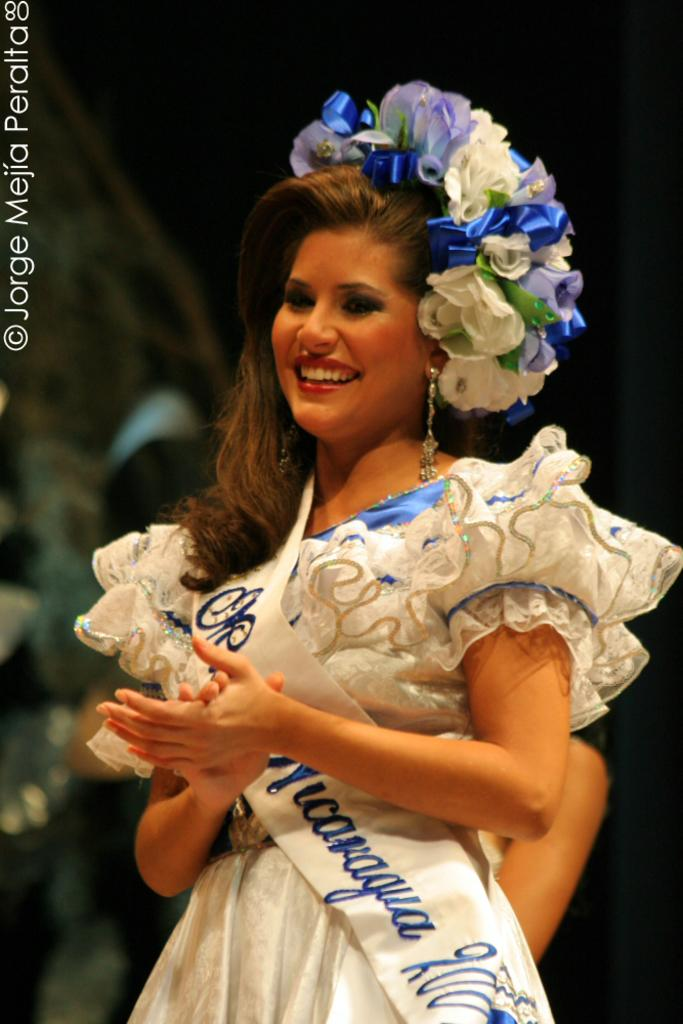<image>
Render a clear and concise summary of the photo. A photograph of a Woman taken by Jorge Mejia. 